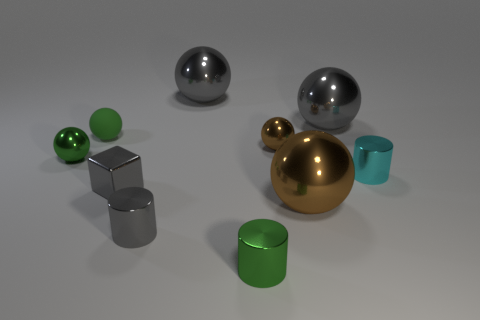Is there anything else that has the same shape as the small brown metal thing?
Provide a short and direct response. Yes. Does the tiny cyan object have the same shape as the tiny green object right of the small gray cylinder?
Provide a short and direct response. Yes. There is another green thing that is the same shape as the rubber thing; what size is it?
Provide a short and direct response. Small. How many other objects are the same material as the tiny gray cube?
Offer a terse response. 8. What is the material of the small gray cube?
Offer a terse response. Metal. There is a shiny cylinder behind the small cube; does it have the same color as the small metal thing to the left of the shiny cube?
Make the answer very short. No. Are there more tiny gray cubes that are in front of the green metal cylinder than small gray metal cylinders?
Your answer should be very brief. No. How many other objects are the same color as the rubber sphere?
Offer a very short reply. 2. There is a brown thing that is behind the cyan metal thing; is its size the same as the matte thing?
Provide a succinct answer. Yes. Are there any purple metallic spheres that have the same size as the matte thing?
Your response must be concise. No. 